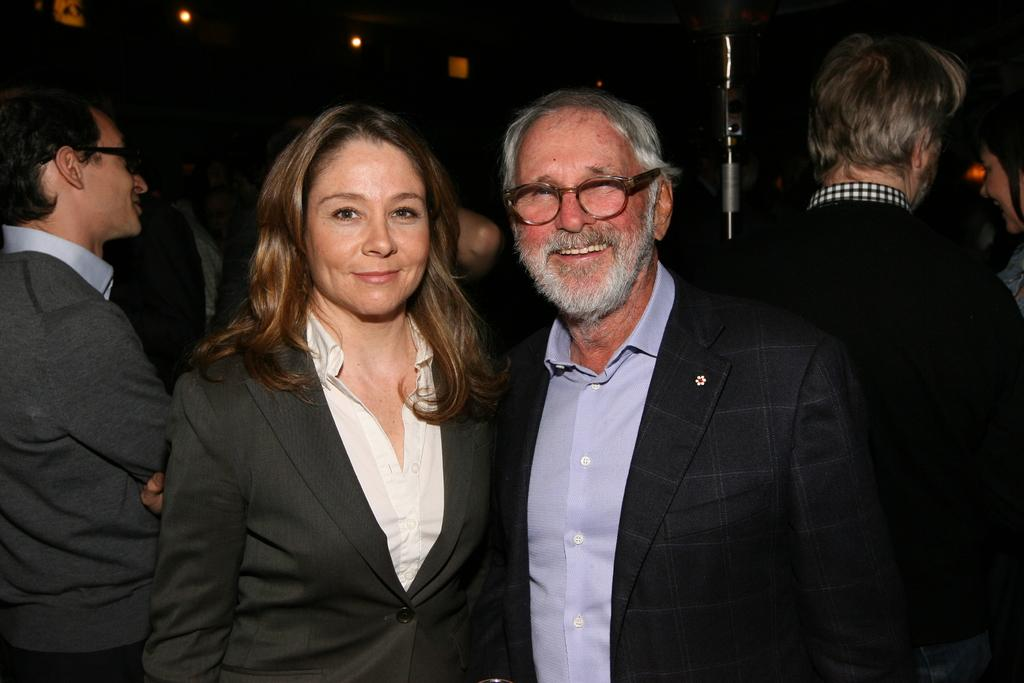What is the main subject of the image? The main subject of the image is people standing. Can you describe what the people are wearing? The people are wearing formal suits. Can you tell me how many boats are visible in the image? There are no boats present in the image. What type of door can be seen in the image? There is no door present in the image. What is the financial status of the people in the image? The financial status of the people cannot be determined from the image, as it only shows them wearing formal suits. 